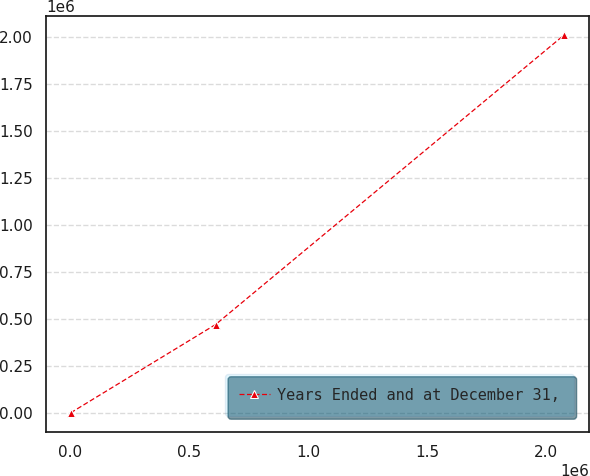<chart> <loc_0><loc_0><loc_500><loc_500><line_chart><ecel><fcel>Years Ended and at December 31,<nl><fcel>1714.67<fcel>2263.13<nl><fcel>610569<fcel>471586<nl><fcel>2.07568e+06<fcel>2.01128e+06<nl></chart> 